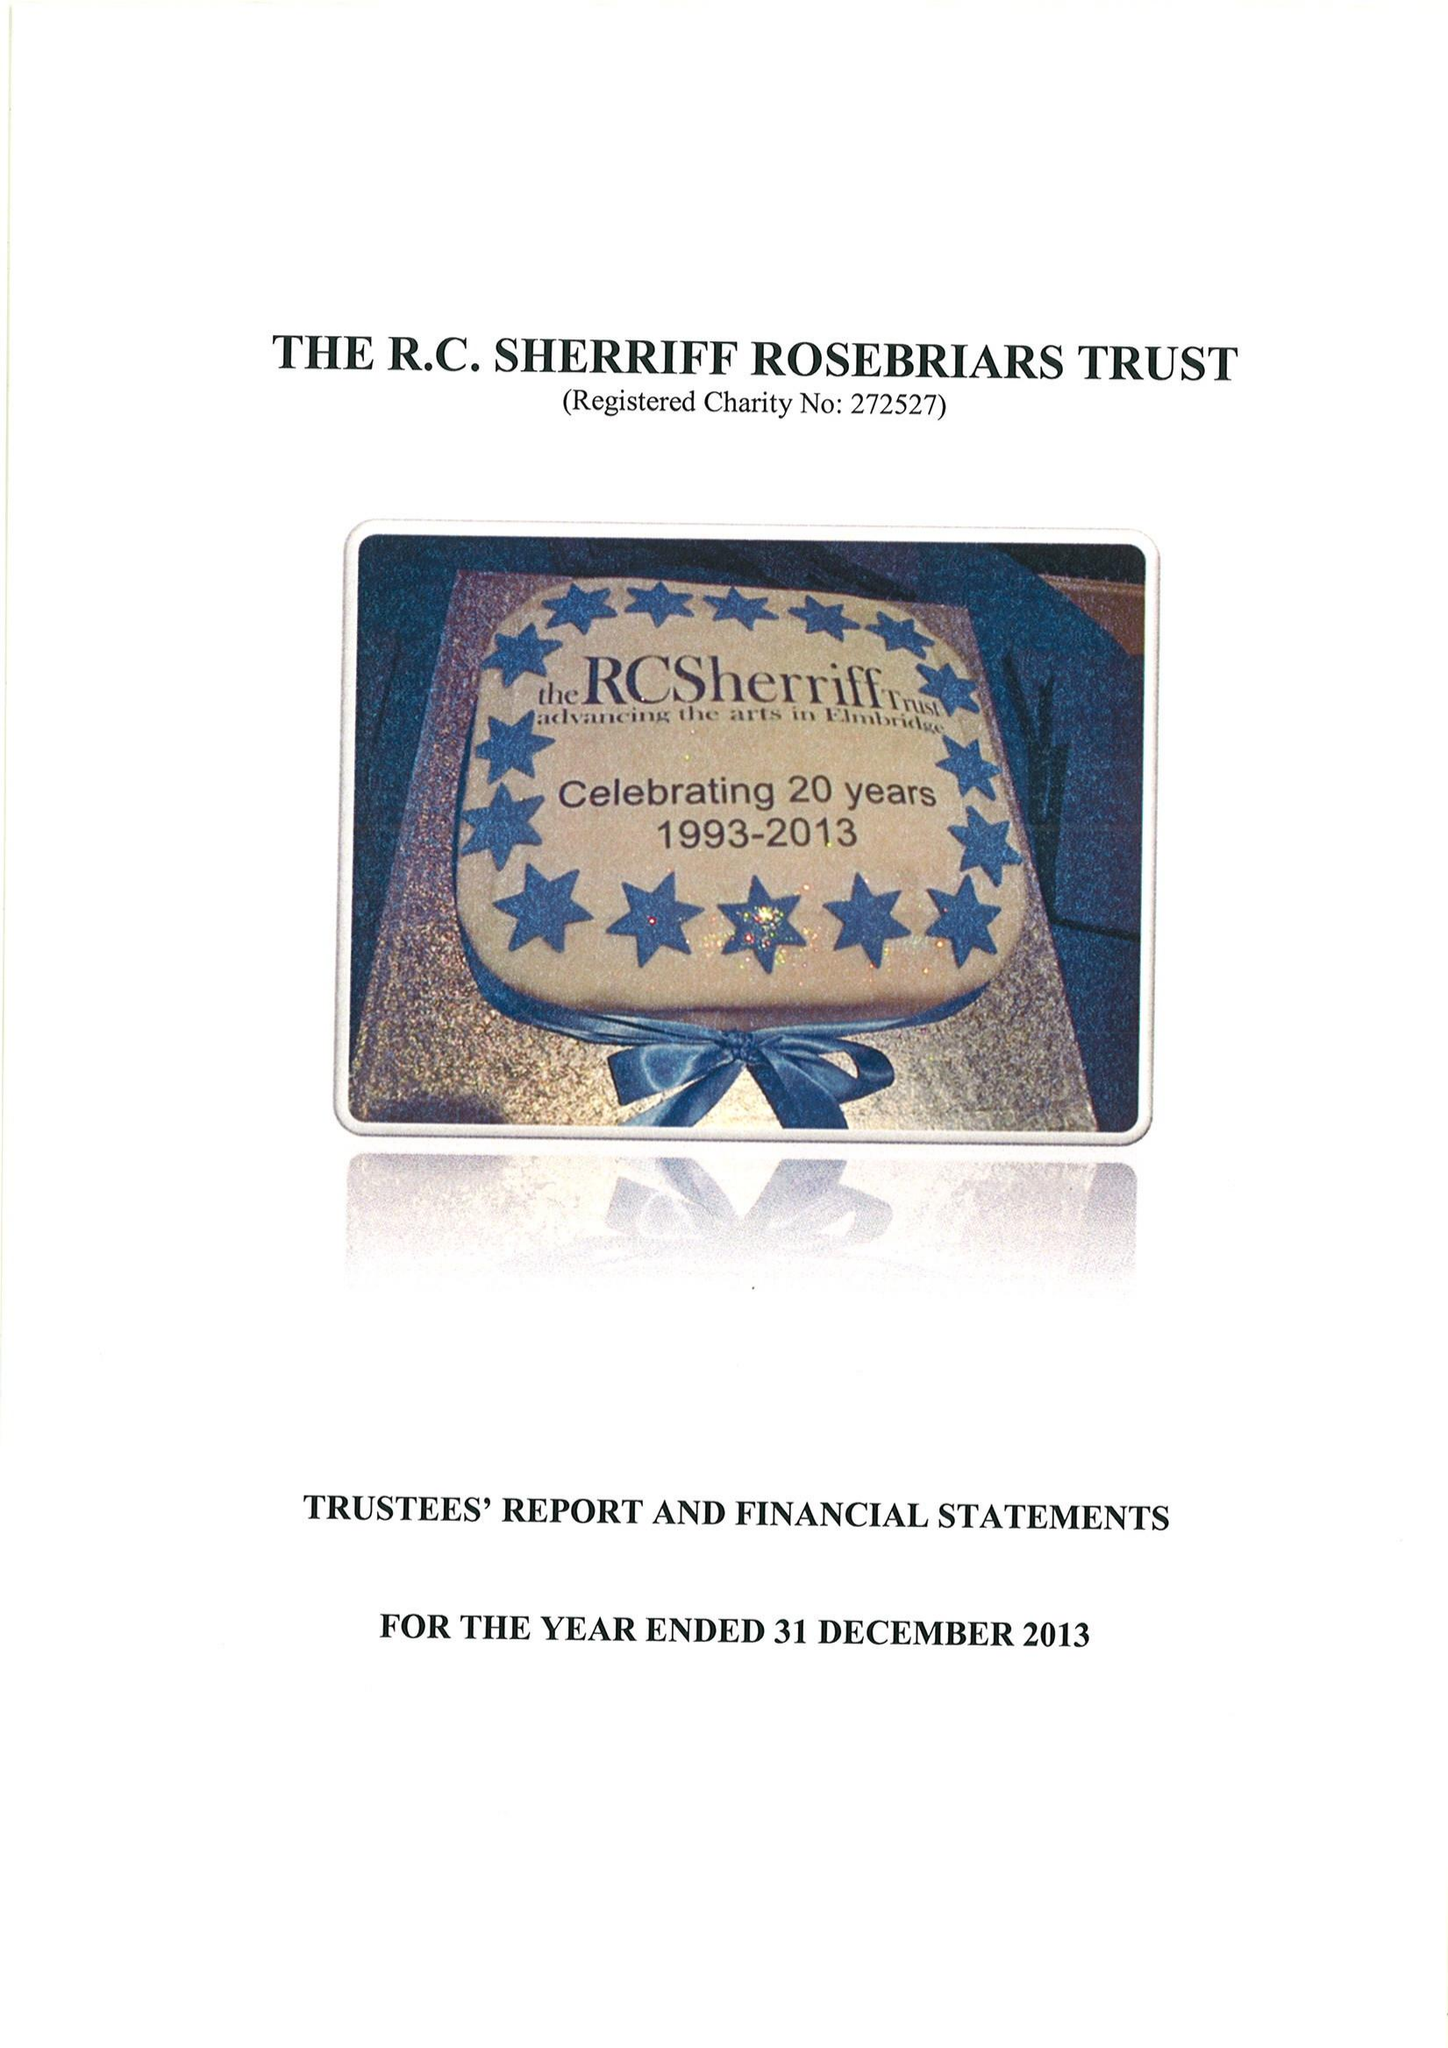What is the value for the address__street_line?
Answer the question using a single word or phrase. HIGH STREET 